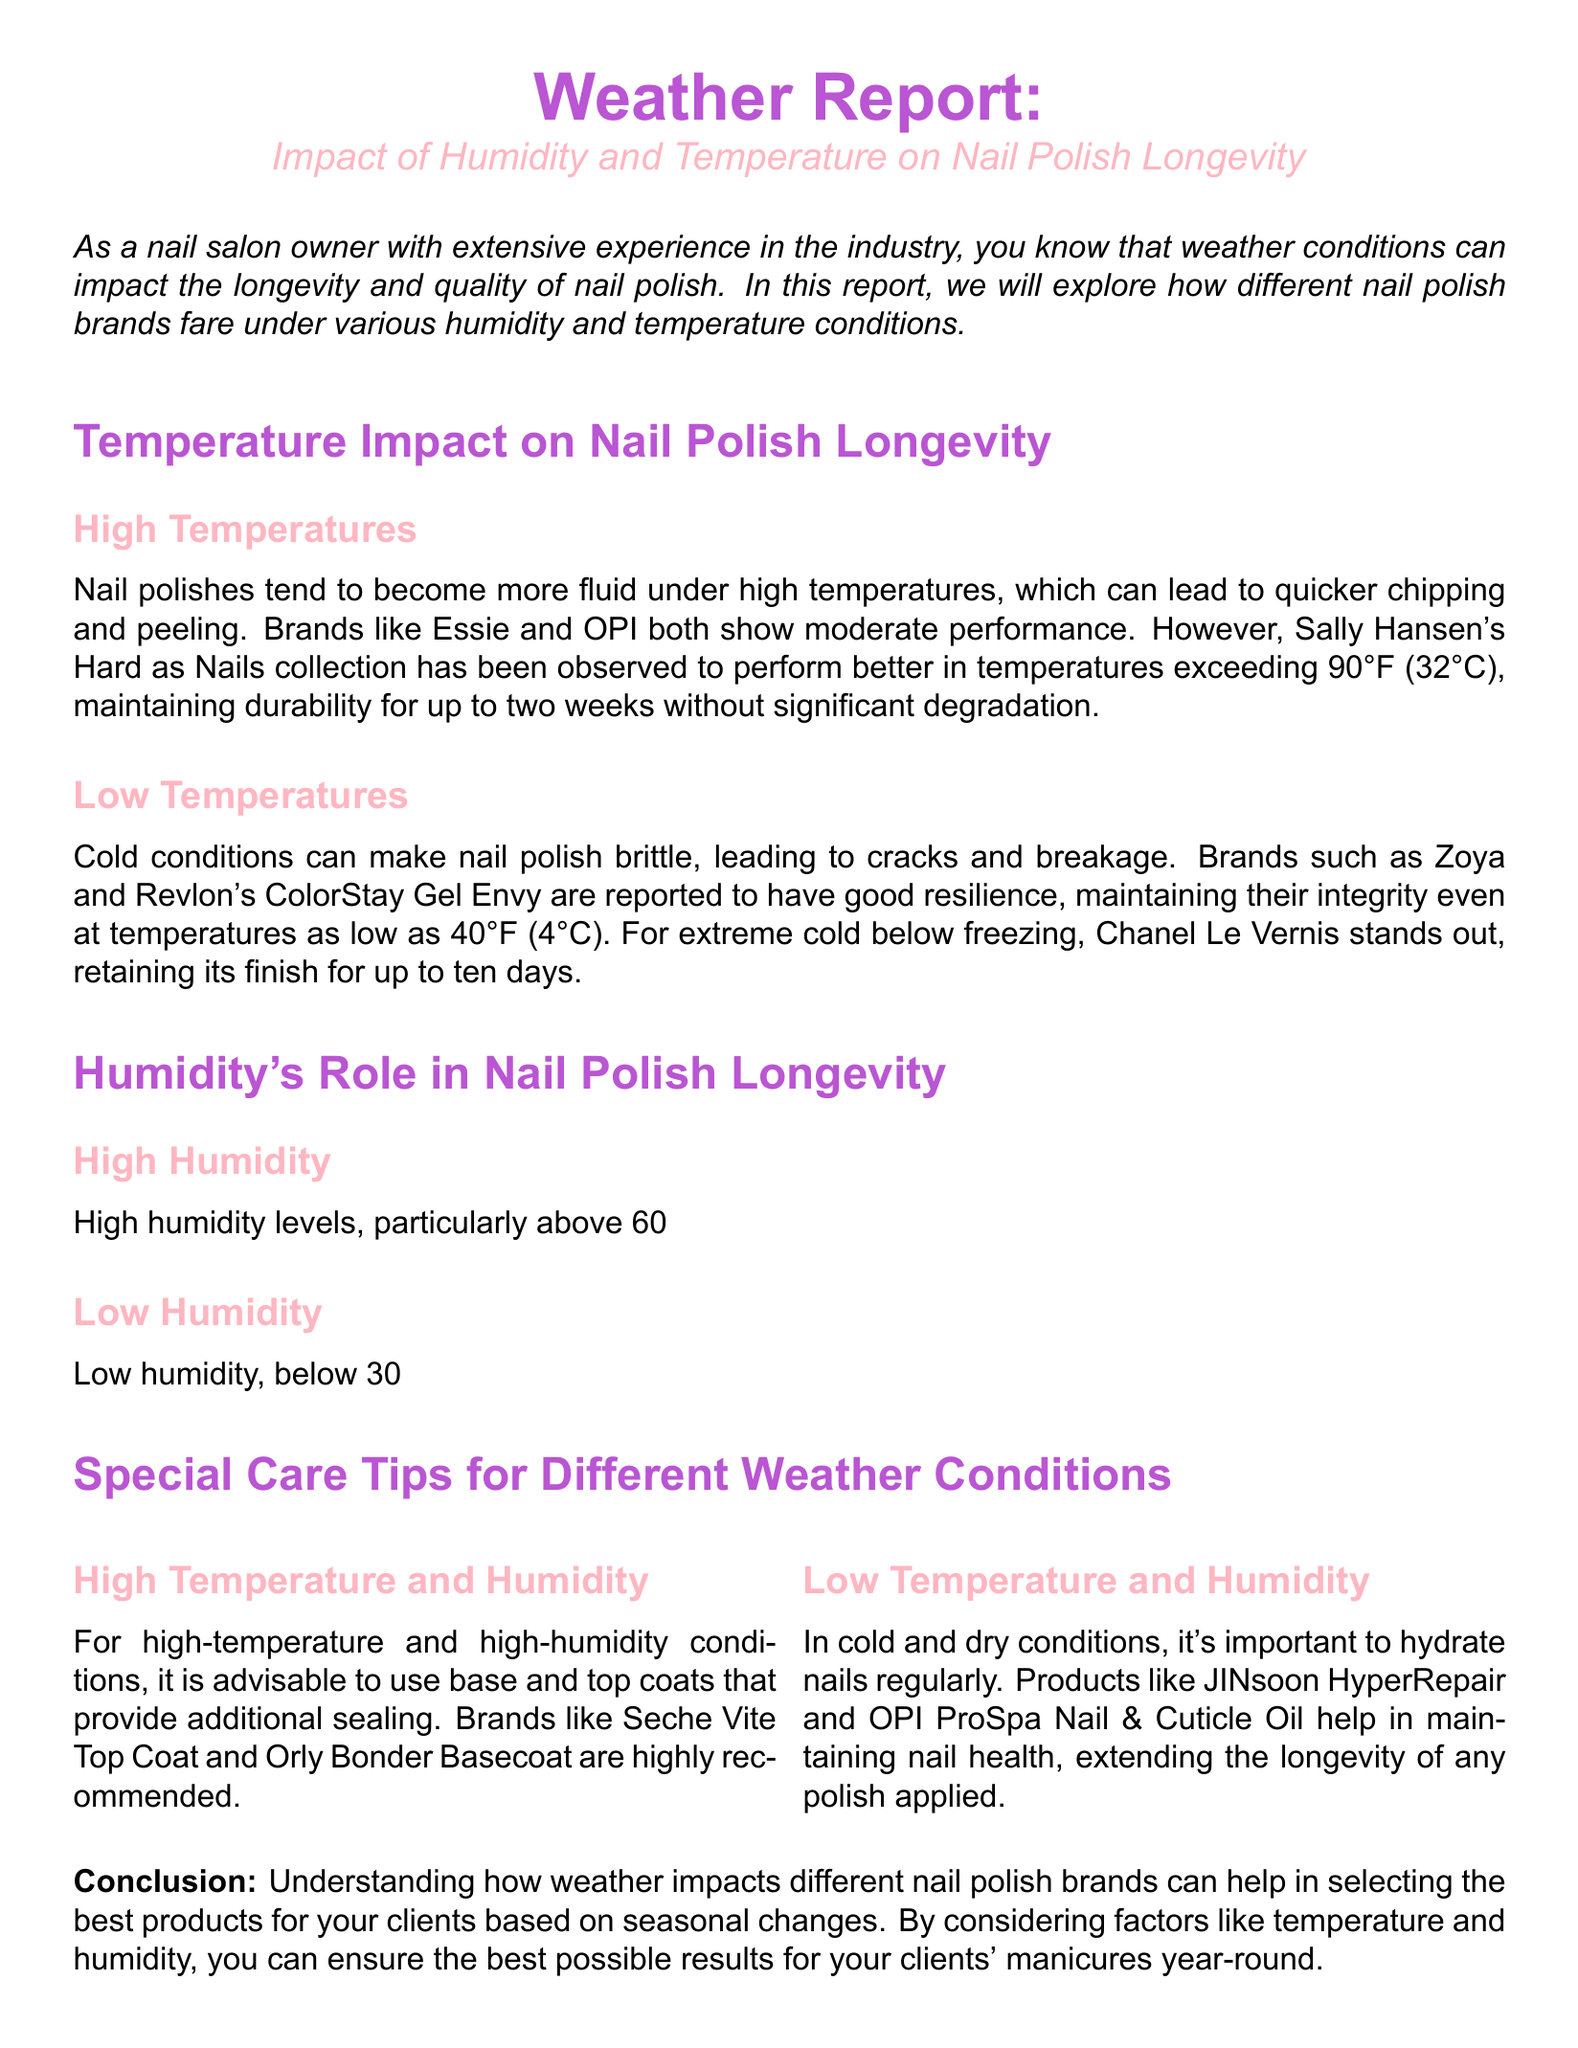What brands perform well in high temperatures? The document lists Essie, OPI, and Sally Hansen as brands that perform in high temperatures, noting Sally Hansen's Hard as Nails as particularly effective.
Answer: Sally Hansen At what temperature do Zoya and Revlon's ColorStay Gel Envy maintain integrity? The document states that these brands maintain integrity at temperatures as low as 40°F.
Answer: 40°F Which gel-based formulas are resistant to high humidity? Gelish and CND Shellac are specifically mentioned as more resistant to high humidity.
Answer: Gelish and CND Shellac What product is highly recommended for high temperature and humidity conditions? The document recommends Seche Vite Top Coat for these conditions.
Answer: Seche Vite Top Coat How long can Chanel Le Vernis retain its finish in extreme cold? The document indicates that Chanel Le Vernis can retain its finish for up to ten days in extreme cold.
Answer: ten days What is the impact of low humidity on nail polish? According to the document, low humidity can lead to faster drying times but increases brittleness.
Answer: Brittleness Which brands show increased longevity in low humidity? The document mentions Deborah Lippmann and Butter London as brands that show increased longevity in low humidity.
Answer: Deborah Lippmann and Butter London What should be used in cold and dry conditions? The document suggests using products like JINsoon HyperRepair and OPI ProSpa Nail & Cuticle Oil in cold and dry conditions.
Answer: JINsoon HyperRepair and OPI ProSpa Nail & Cuticle Oil What happens to nail polish under high temperatures? The document explains that nail polishes become more fluid under high temperatures, leading to quicker chipping and peeling.
Answer: Quicker chipping and peeling 